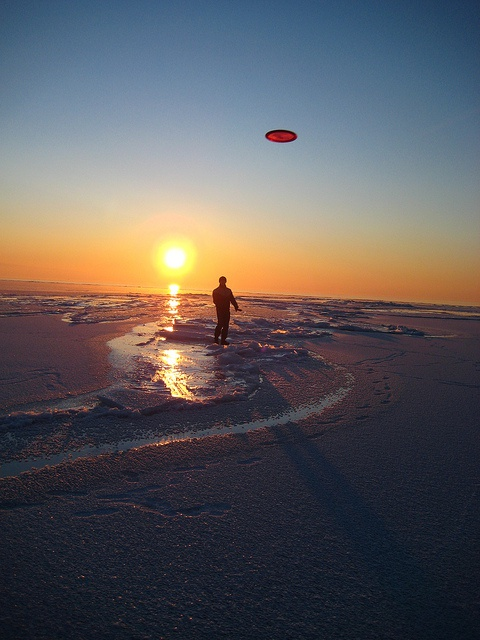Describe the objects in this image and their specific colors. I can see people in darkblue, black, maroon, orange, and brown tones and frisbee in darkblue, brown, maroon, black, and gray tones in this image. 